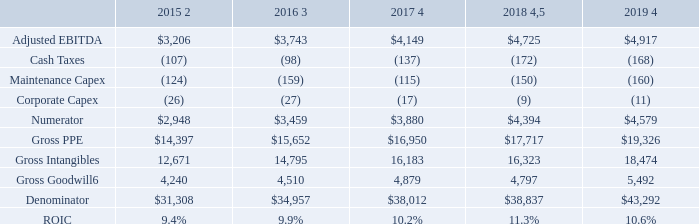American Tower Corporation • 2019 Annual Report
Appendix 1 • Letter to Stakeholders
RETURN ON INVESTED CAPITAL (ROIC) RECONCILIATION1 ($ in millions. Totals may not add due to rounding.)
1 Historical denominator balances reflect purchase accounting adjustments
2 Represents Q4 2015 annualized numbers to account for full year impact of Verizon Transaction.
3 Represents Q4 2016 annualized numbers to account for full year impact of Viom Transaction
4 Adjusted to annualize impacts of acquisitions closed throughout the year.
5 Positively impacted by the Company's settlement with Tata in Q4 2018.
6 Excludes the impact of deferred tax adjustments related to valuation.
What does Gross Goodwill exclude? The impact of deferred tax adjustments related to valuation. What was the ROIC in 2015? 9.4%. What was the gross PPE in 2016?
Answer scale should be: million. $15,652. What was the change in adjusted EBITDA between 2016 and 2017?
Answer scale should be: million. $4,149-$3,743
Answer: 406. How many years did gross intangibles exceed $15,000 million? 2017##2018##2019
Answer: 3. What was the percentage change in gross goodwill between 2018 and 2019?
Answer scale should be: percent. (5,492-4,797)/4,797
Answer: 14.49. 